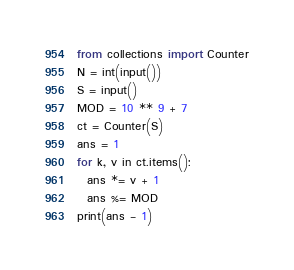<code> <loc_0><loc_0><loc_500><loc_500><_Python_>from collections import Counter
N = int(input())
S = input()
MOD = 10 ** 9 + 7
ct = Counter(S)
ans = 1
for k, v in ct.items():
  ans *= v + 1
  ans %= MOD
print(ans - 1)</code> 